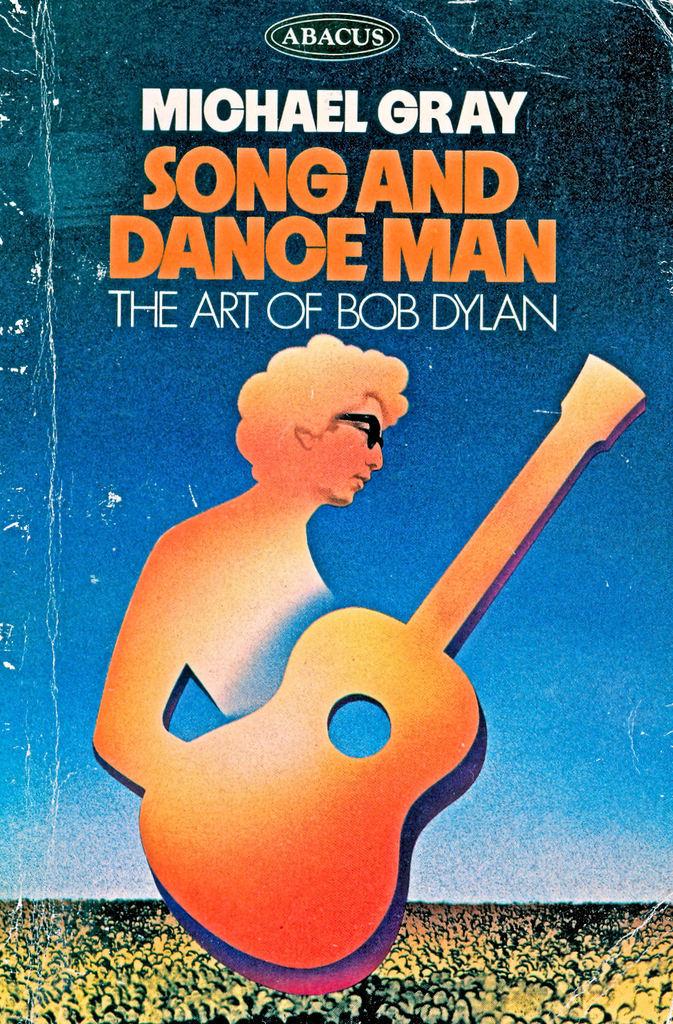Who wrote this book?
Offer a very short reply. Michael gray. Is this for the weekend evening show?
Your response must be concise. No. 